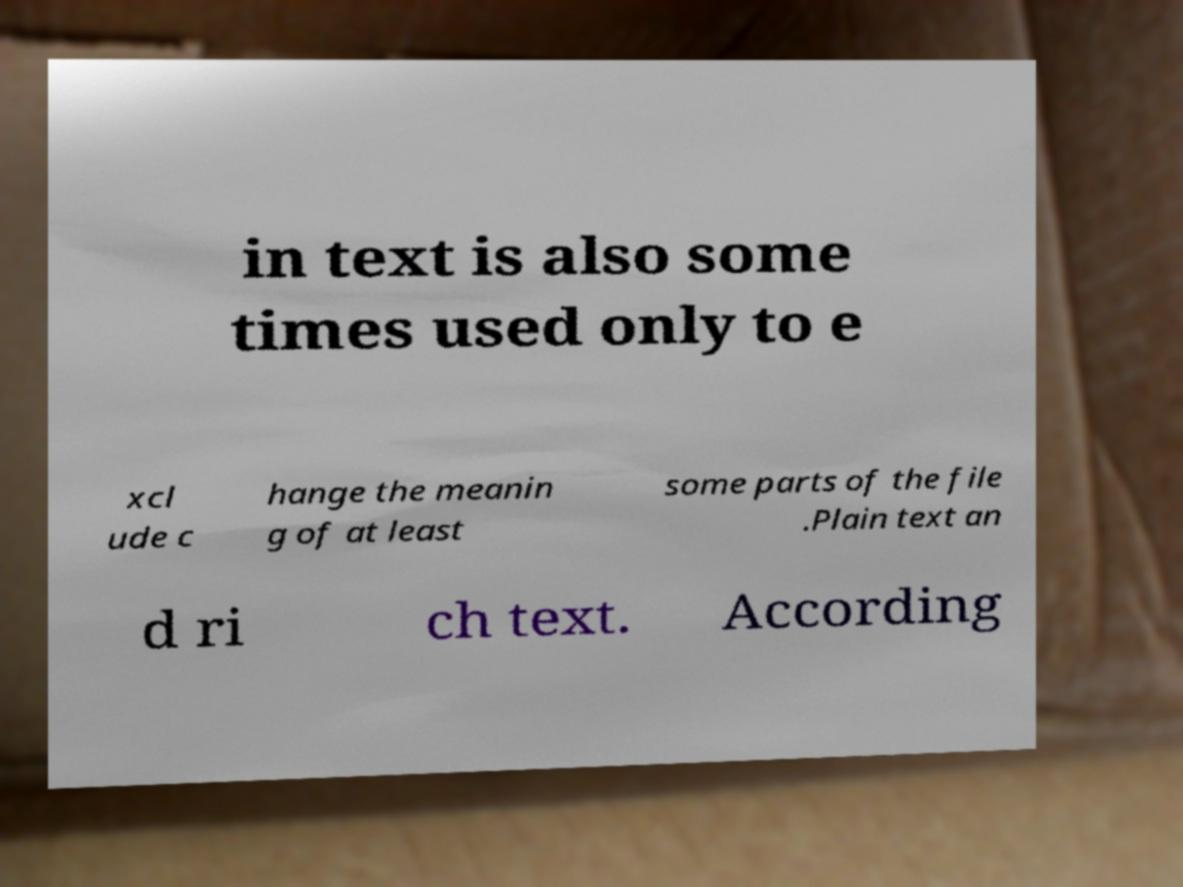Please identify and transcribe the text found in this image. in text is also some times used only to e xcl ude c hange the meanin g of at least some parts of the file .Plain text an d ri ch text. According 